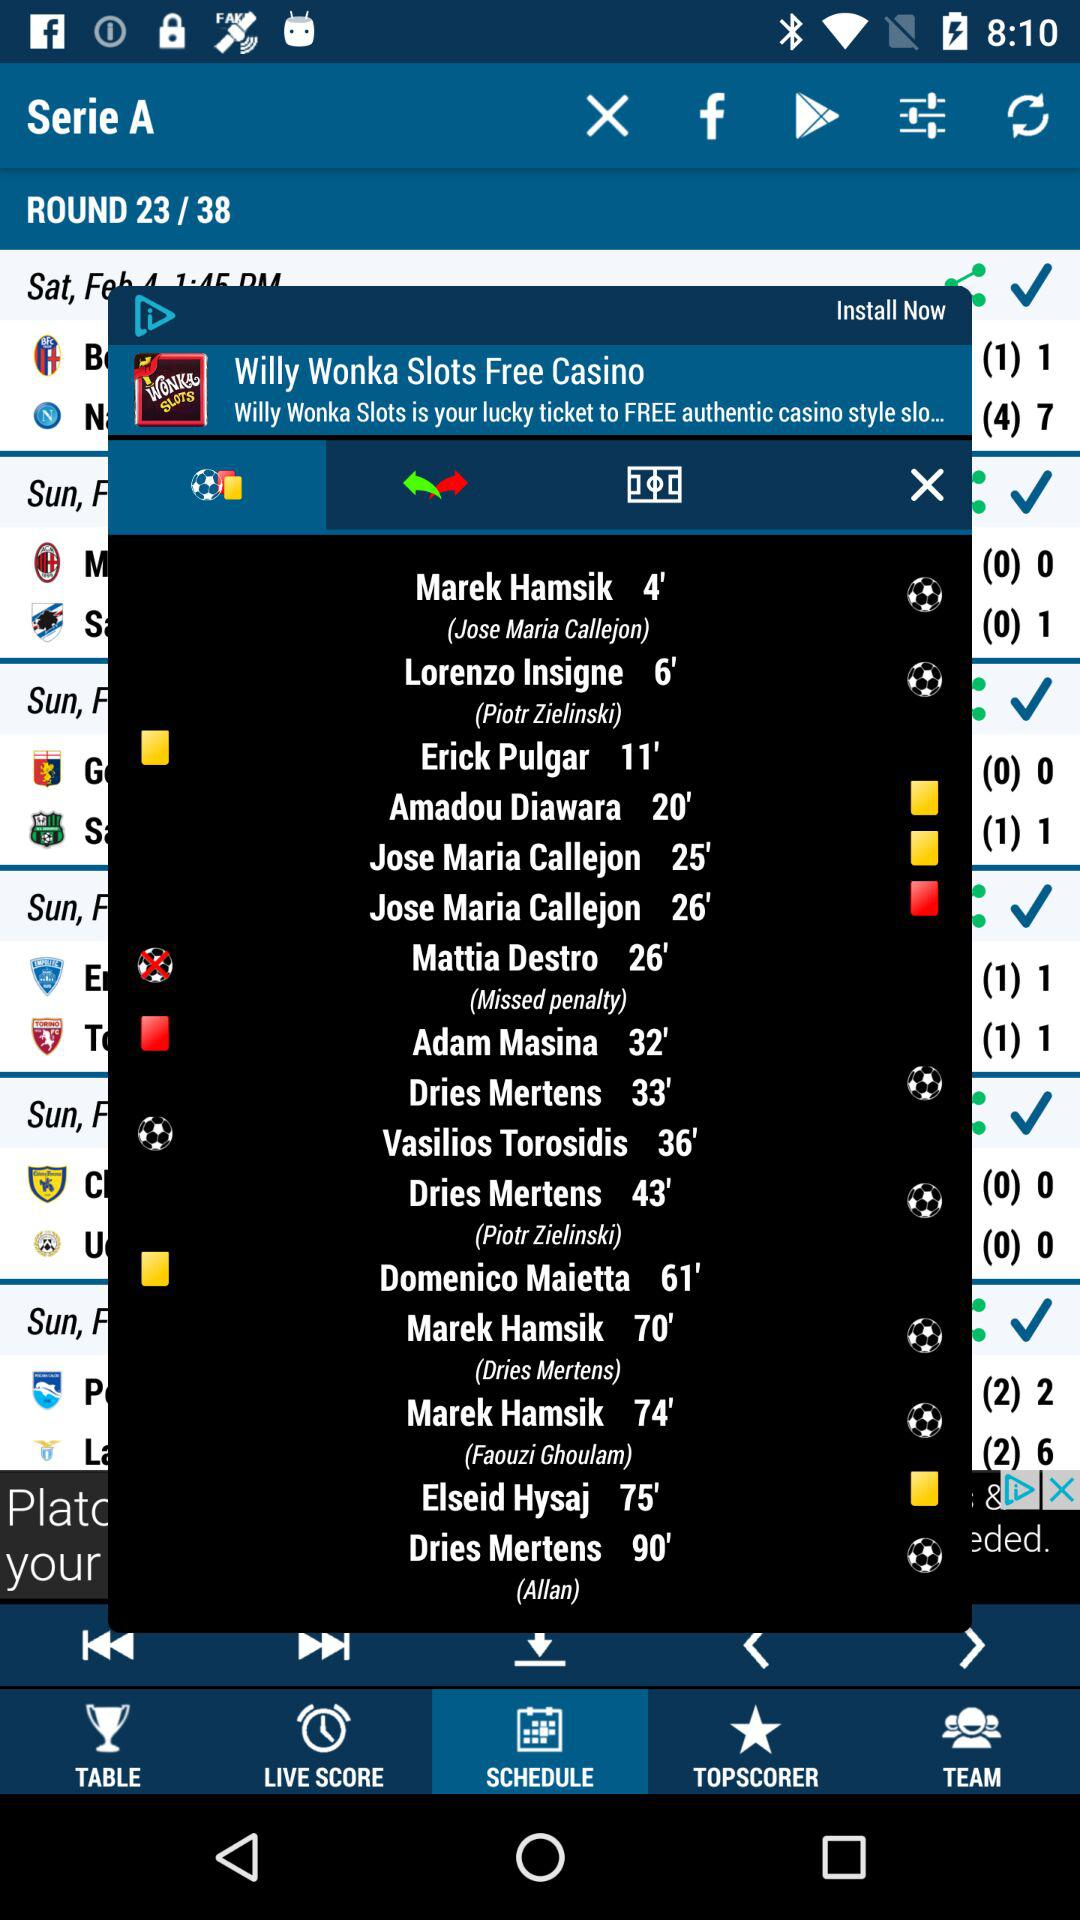How many notifications are there in "TEAM"?
When the provided information is insufficient, respond with <no answer>. <no answer> 